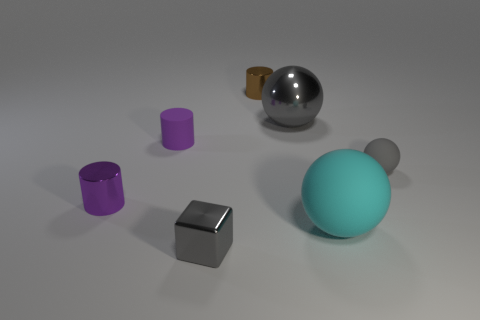Can you describe the materials the objects might be made of? The shiny sphere seems to be metallic, likely steel or chrome, given its reflective surface. The purple cylinders and the smaller sphere appear to have a matte finish, suggesting a plastic or ceramic material. The small gray object, also with a matte finish, could be a light metal or hard plastic. 